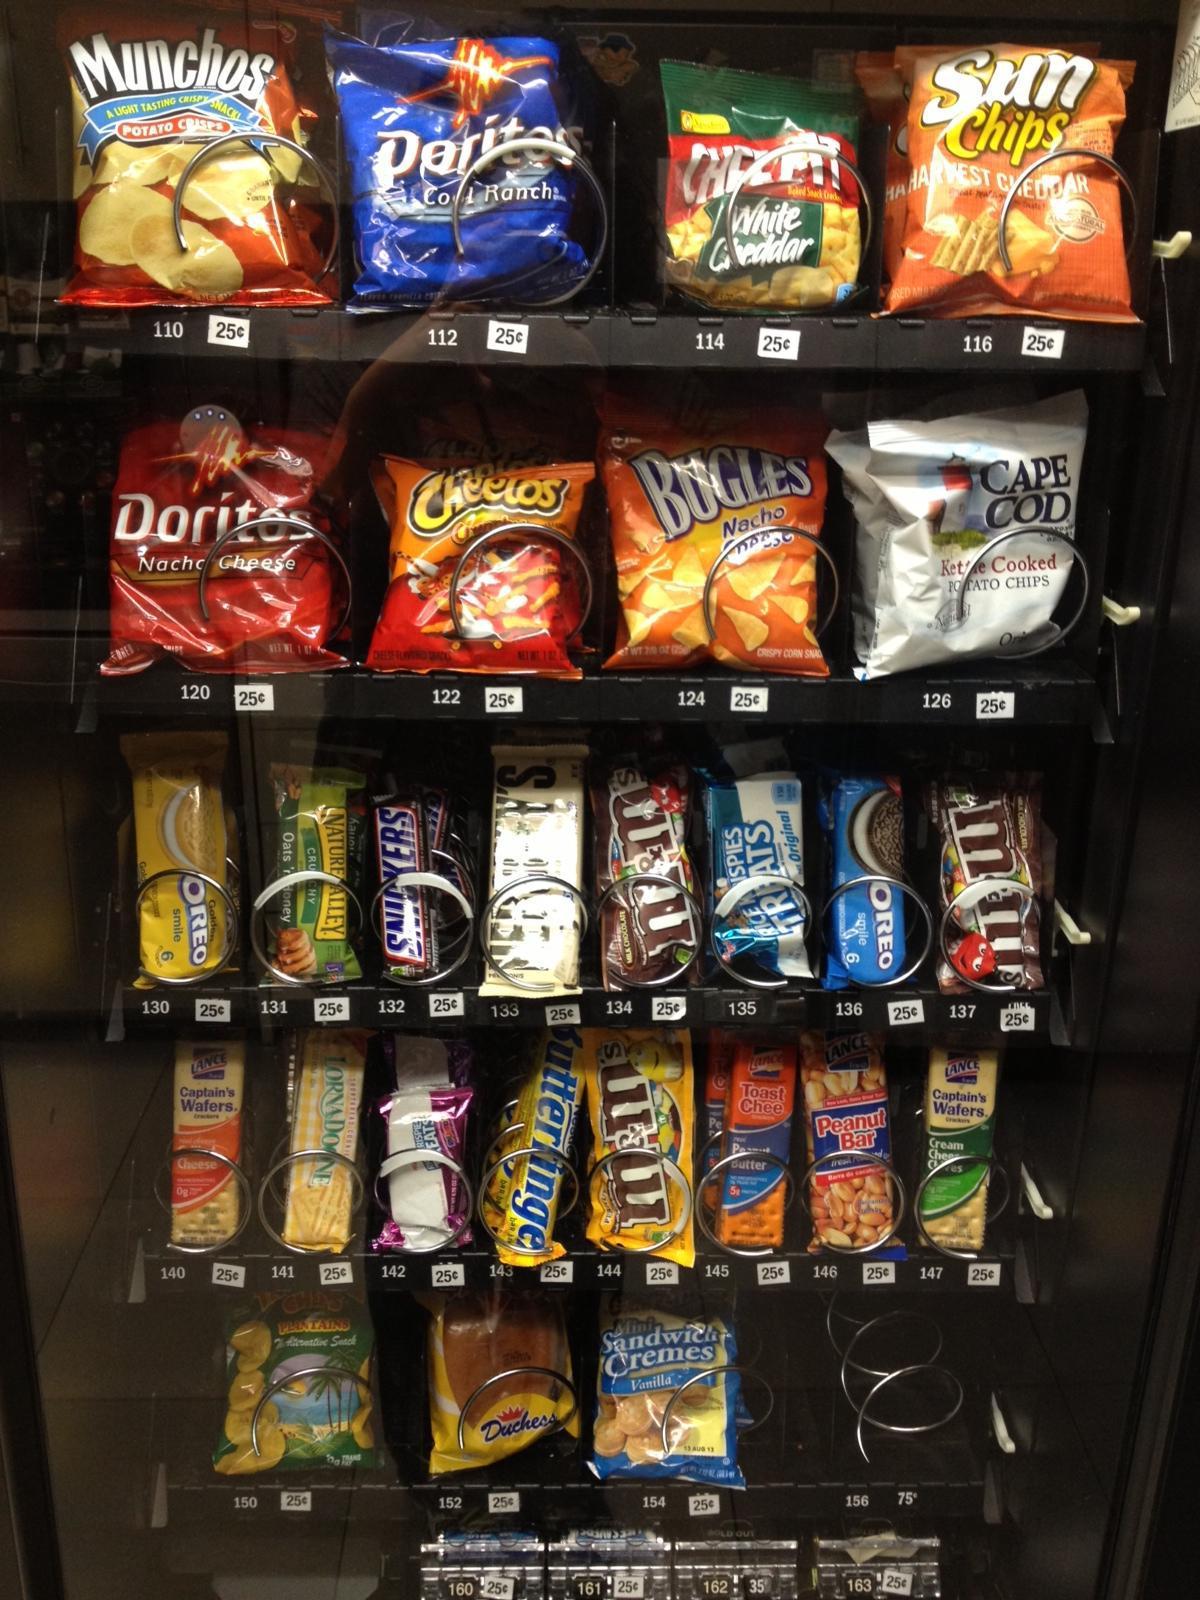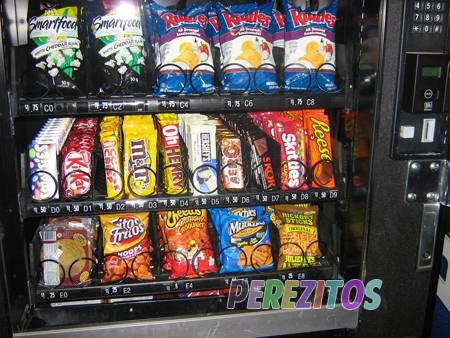The first image is the image on the left, the second image is the image on the right. For the images shown, is this caption "At least one vending machine is loaded with drinks." true? Answer yes or no. No. 